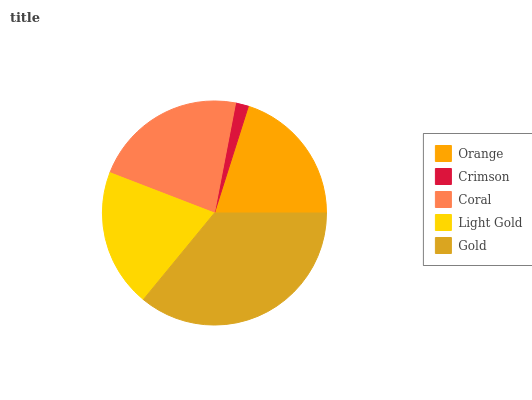Is Crimson the minimum?
Answer yes or no. Yes. Is Gold the maximum?
Answer yes or no. Yes. Is Coral the minimum?
Answer yes or no. No. Is Coral the maximum?
Answer yes or no. No. Is Coral greater than Crimson?
Answer yes or no. Yes. Is Crimson less than Coral?
Answer yes or no. Yes. Is Crimson greater than Coral?
Answer yes or no. No. Is Coral less than Crimson?
Answer yes or no. No. Is Orange the high median?
Answer yes or no. Yes. Is Orange the low median?
Answer yes or no. Yes. Is Crimson the high median?
Answer yes or no. No. Is Crimson the low median?
Answer yes or no. No. 